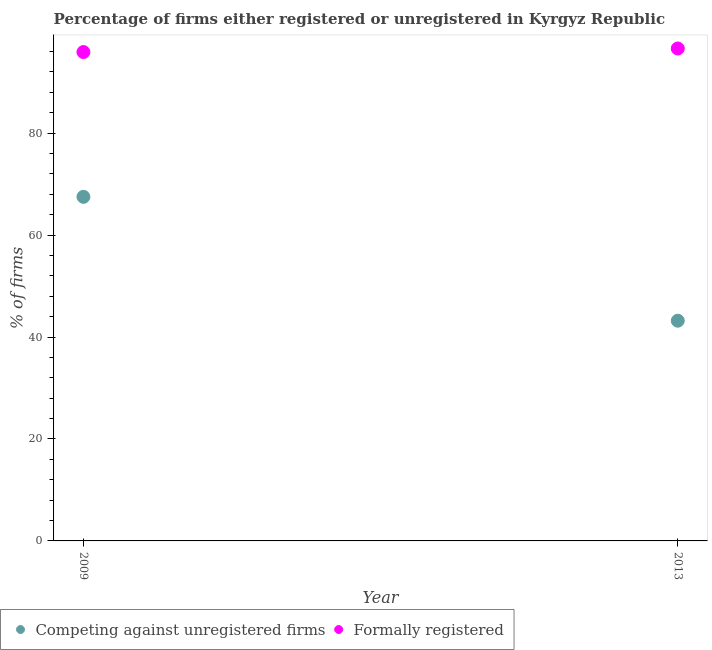How many different coloured dotlines are there?
Provide a short and direct response. 2. What is the percentage of formally registered firms in 2013?
Your response must be concise. 96.6. Across all years, what is the maximum percentage of formally registered firms?
Make the answer very short. 96.6. Across all years, what is the minimum percentage of formally registered firms?
Make the answer very short. 95.9. In which year was the percentage of formally registered firms maximum?
Provide a succinct answer. 2013. In which year was the percentage of registered firms minimum?
Ensure brevity in your answer.  2013. What is the total percentage of formally registered firms in the graph?
Make the answer very short. 192.5. What is the difference between the percentage of formally registered firms in 2009 and that in 2013?
Your response must be concise. -0.7. What is the difference between the percentage of formally registered firms in 2013 and the percentage of registered firms in 2009?
Your response must be concise. 29.1. What is the average percentage of registered firms per year?
Ensure brevity in your answer.  55.35. In the year 2013, what is the difference between the percentage of registered firms and percentage of formally registered firms?
Ensure brevity in your answer.  -53.4. What is the ratio of the percentage of registered firms in 2009 to that in 2013?
Provide a succinct answer. 1.56. In how many years, is the percentage of registered firms greater than the average percentage of registered firms taken over all years?
Provide a succinct answer. 1. Is the percentage of formally registered firms strictly less than the percentage of registered firms over the years?
Provide a short and direct response. No. How many years are there in the graph?
Offer a terse response. 2. What is the difference between two consecutive major ticks on the Y-axis?
Keep it short and to the point. 20. Are the values on the major ticks of Y-axis written in scientific E-notation?
Your answer should be very brief. No. Does the graph contain grids?
Offer a terse response. No. Where does the legend appear in the graph?
Give a very brief answer. Bottom left. How are the legend labels stacked?
Offer a terse response. Horizontal. What is the title of the graph?
Give a very brief answer. Percentage of firms either registered or unregistered in Kyrgyz Republic. Does "Arms exports" appear as one of the legend labels in the graph?
Your answer should be compact. No. What is the label or title of the X-axis?
Give a very brief answer. Year. What is the label or title of the Y-axis?
Ensure brevity in your answer.  % of firms. What is the % of firms in Competing against unregistered firms in 2009?
Keep it short and to the point. 67.5. What is the % of firms in Formally registered in 2009?
Provide a succinct answer. 95.9. What is the % of firms in Competing against unregistered firms in 2013?
Ensure brevity in your answer.  43.2. What is the % of firms in Formally registered in 2013?
Keep it short and to the point. 96.6. Across all years, what is the maximum % of firms of Competing against unregistered firms?
Your answer should be very brief. 67.5. Across all years, what is the maximum % of firms of Formally registered?
Provide a short and direct response. 96.6. Across all years, what is the minimum % of firms in Competing against unregistered firms?
Your response must be concise. 43.2. Across all years, what is the minimum % of firms of Formally registered?
Provide a succinct answer. 95.9. What is the total % of firms of Competing against unregistered firms in the graph?
Your answer should be very brief. 110.7. What is the total % of firms in Formally registered in the graph?
Provide a succinct answer. 192.5. What is the difference between the % of firms in Competing against unregistered firms in 2009 and that in 2013?
Provide a succinct answer. 24.3. What is the difference between the % of firms in Formally registered in 2009 and that in 2013?
Your answer should be very brief. -0.7. What is the difference between the % of firms of Competing against unregistered firms in 2009 and the % of firms of Formally registered in 2013?
Give a very brief answer. -29.1. What is the average % of firms in Competing against unregistered firms per year?
Offer a terse response. 55.35. What is the average % of firms in Formally registered per year?
Offer a terse response. 96.25. In the year 2009, what is the difference between the % of firms in Competing against unregistered firms and % of firms in Formally registered?
Provide a short and direct response. -28.4. In the year 2013, what is the difference between the % of firms in Competing against unregistered firms and % of firms in Formally registered?
Offer a very short reply. -53.4. What is the ratio of the % of firms of Competing against unregistered firms in 2009 to that in 2013?
Give a very brief answer. 1.56. What is the difference between the highest and the second highest % of firms of Competing against unregistered firms?
Your answer should be very brief. 24.3. What is the difference between the highest and the lowest % of firms in Competing against unregistered firms?
Make the answer very short. 24.3. 